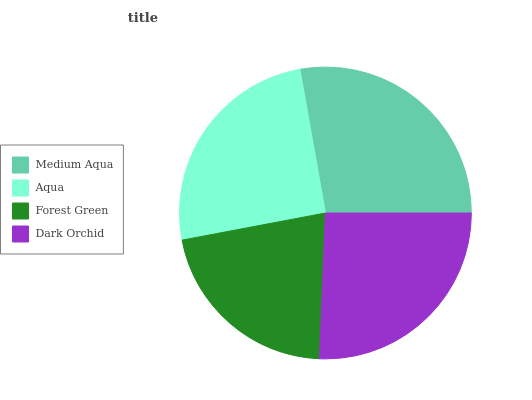Is Forest Green the minimum?
Answer yes or no. Yes. Is Medium Aqua the maximum?
Answer yes or no. Yes. Is Aqua the minimum?
Answer yes or no. No. Is Aqua the maximum?
Answer yes or no. No. Is Medium Aqua greater than Aqua?
Answer yes or no. Yes. Is Aqua less than Medium Aqua?
Answer yes or no. Yes. Is Aqua greater than Medium Aqua?
Answer yes or no. No. Is Medium Aqua less than Aqua?
Answer yes or no. No. Is Dark Orchid the high median?
Answer yes or no. Yes. Is Aqua the low median?
Answer yes or no. Yes. Is Aqua the high median?
Answer yes or no. No. Is Dark Orchid the low median?
Answer yes or no. No. 